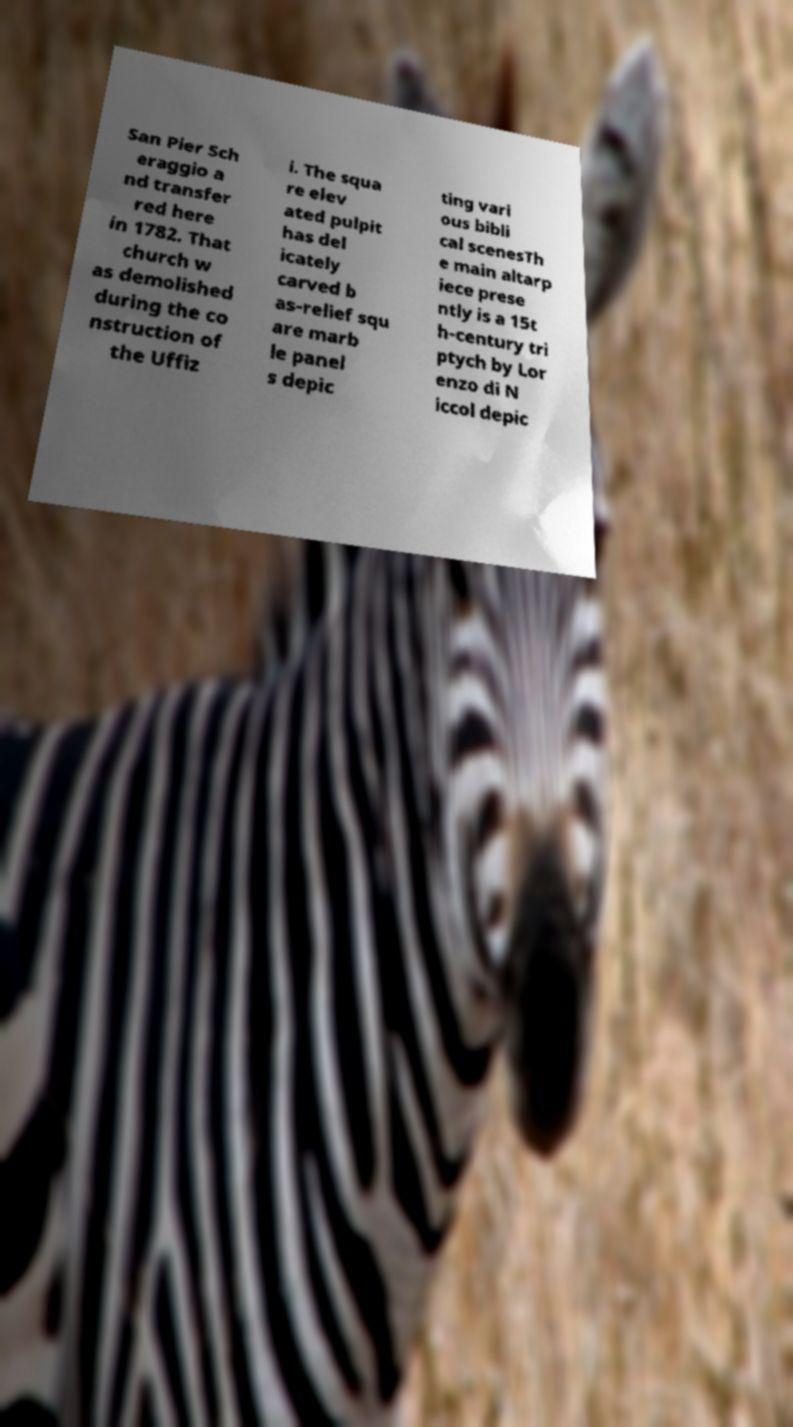Could you assist in decoding the text presented in this image and type it out clearly? San Pier Sch eraggio a nd transfer red here in 1782. That church w as demolished during the co nstruction of the Uffiz i. The squa re elev ated pulpit has del icately carved b as-relief squ are marb le panel s depic ting vari ous bibli cal scenesTh e main altarp iece prese ntly is a 15t h-century tri ptych by Lor enzo di N iccol depic 